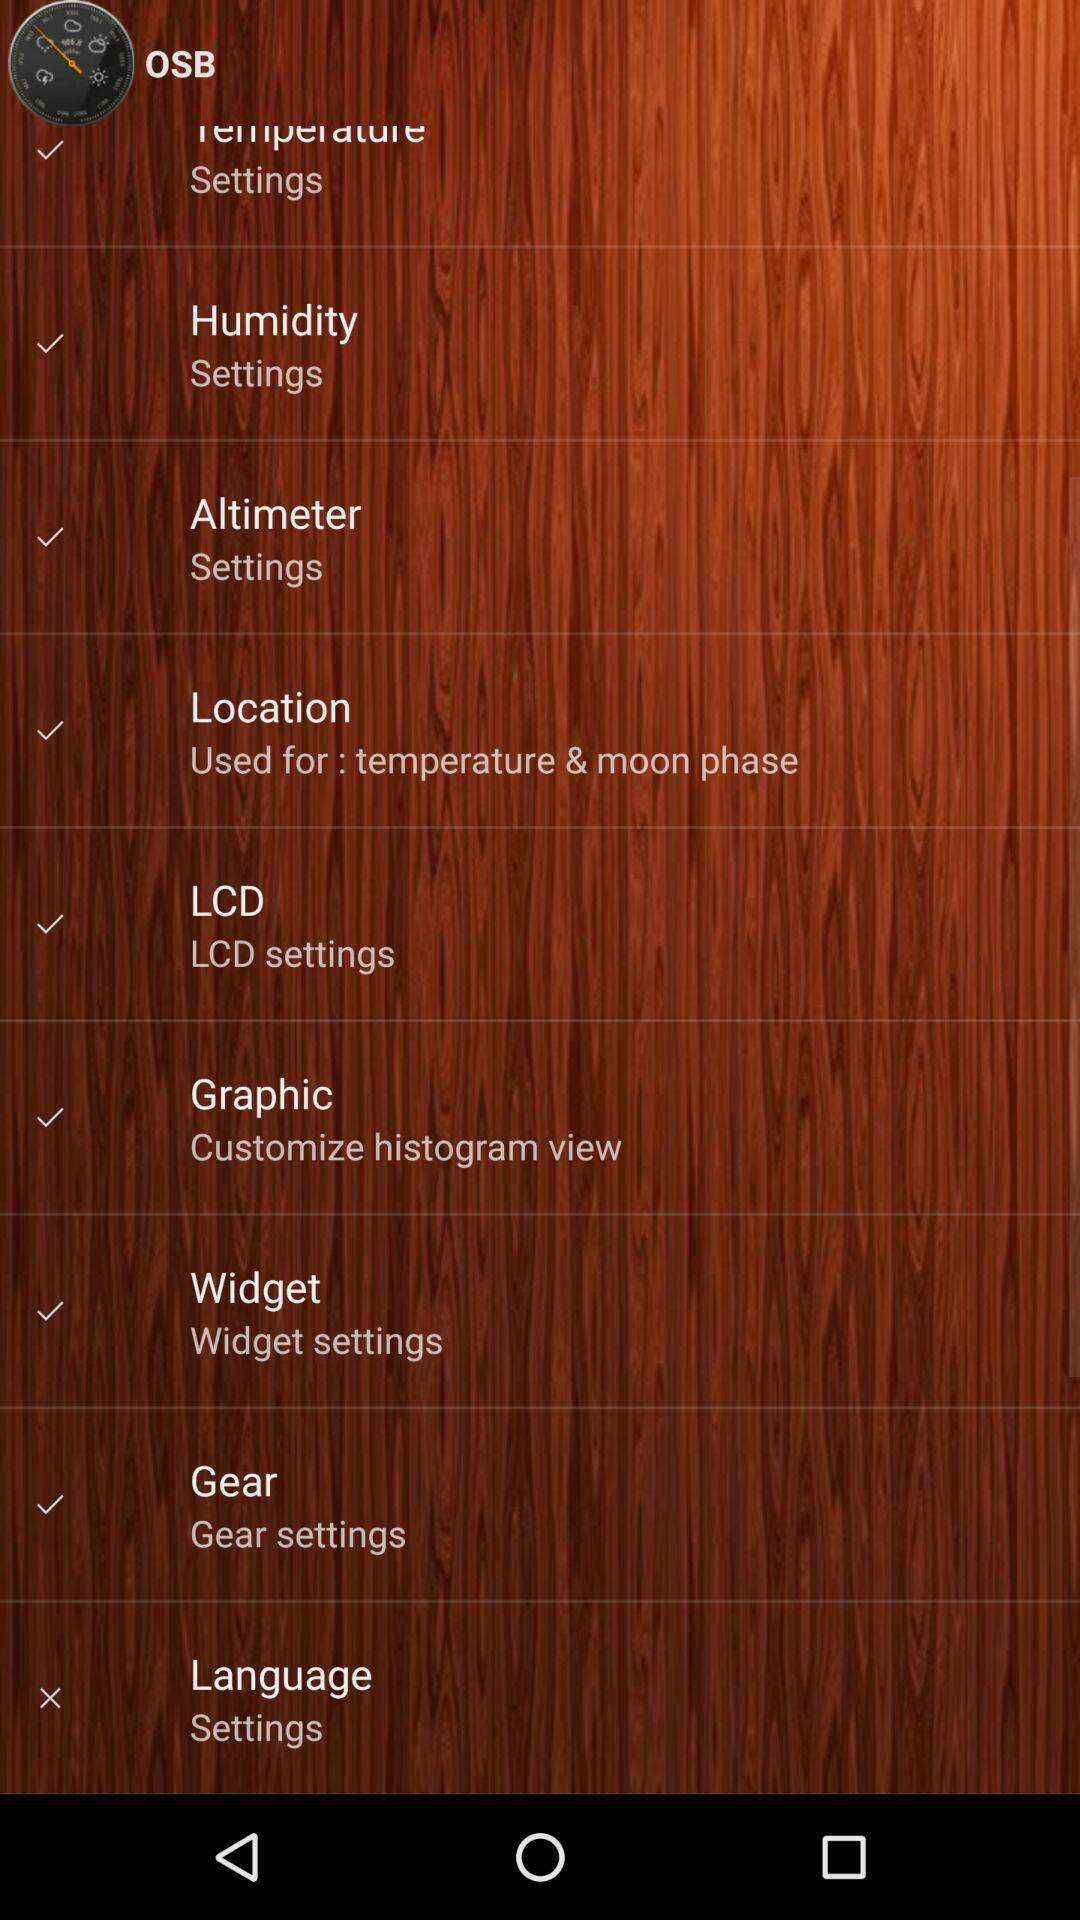Which of the options has been marked as crossed? The crossed option is "Language". 